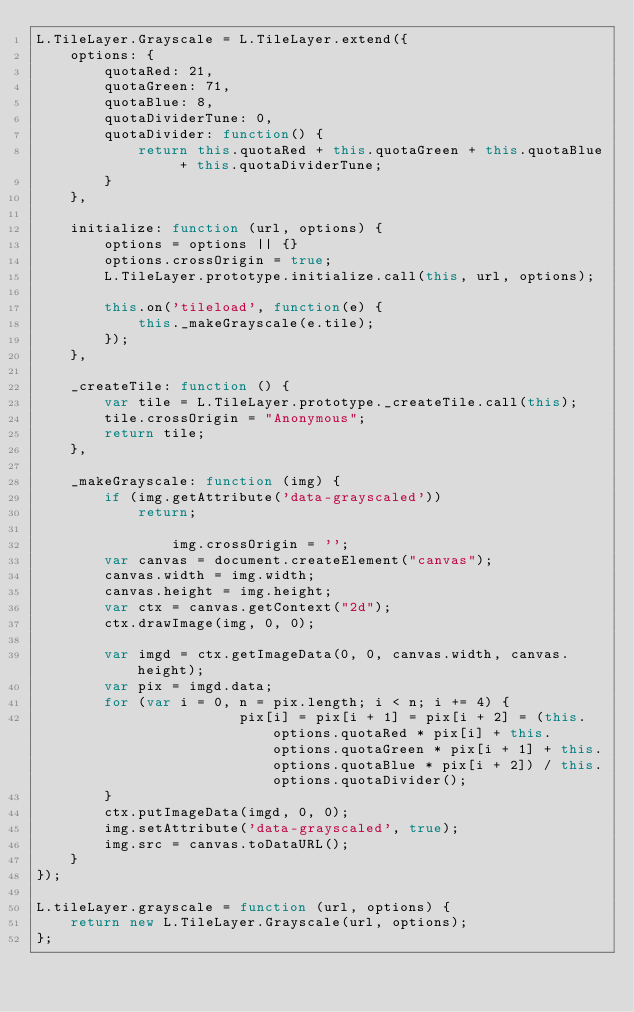<code> <loc_0><loc_0><loc_500><loc_500><_JavaScript_>L.TileLayer.Grayscale = L.TileLayer.extend({
	options: {
		quotaRed: 21,
		quotaGreen: 71,
		quotaBlue: 8,
		quotaDividerTune: 0,
		quotaDivider: function() {
			return this.quotaRed + this.quotaGreen + this.quotaBlue + this.quotaDividerTune;
		}
	},

	initialize: function (url, options) {
		options = options || {}
		options.crossOrigin = true;
		L.TileLayer.prototype.initialize.call(this, url, options);

		this.on('tileload', function(e) {
			this._makeGrayscale(e.tile);
		});
	},

	_createTile: function () {
		var tile = L.TileLayer.prototype._createTile.call(this);
		tile.crossOrigin = "Anonymous";
		return tile;
	},

	_makeGrayscale: function (img) {
		if (img.getAttribute('data-grayscaled'))
			return;

                img.crossOrigin = '';
		var canvas = document.createElement("canvas");
		canvas.width = img.width;
		canvas.height = img.height;
		var ctx = canvas.getContext("2d");
		ctx.drawImage(img, 0, 0);

		var imgd = ctx.getImageData(0, 0, canvas.width, canvas.height);
		var pix = imgd.data;
		for (var i = 0, n = pix.length; i < n; i += 4) {
                        pix[i] = pix[i + 1] = pix[i + 2] = (this.options.quotaRed * pix[i] + this.options.quotaGreen * pix[i + 1] + this.options.quotaBlue * pix[i + 2]) / this.options.quotaDivider();
		}
		ctx.putImageData(imgd, 0, 0);
		img.setAttribute('data-grayscaled', true);
		img.src = canvas.toDataURL();
	}
});

L.tileLayer.grayscale = function (url, options) {
	return new L.TileLayer.Grayscale(url, options);
};</code> 